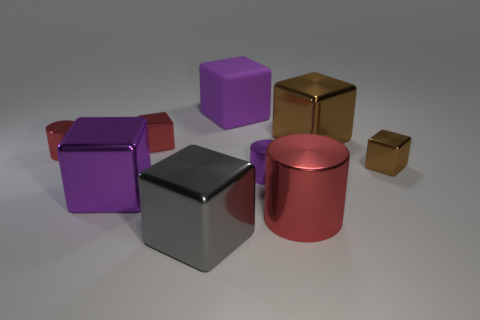Is the large brown block made of the same material as the red cylinder that is to the right of the purple matte block? While the image does not allow us to assess the material composition with absolute certainty, the large brown block appears to have a similar reflective surface to the red cylinder nearby, suggesting they could be made of the same or at least very similar materials. 